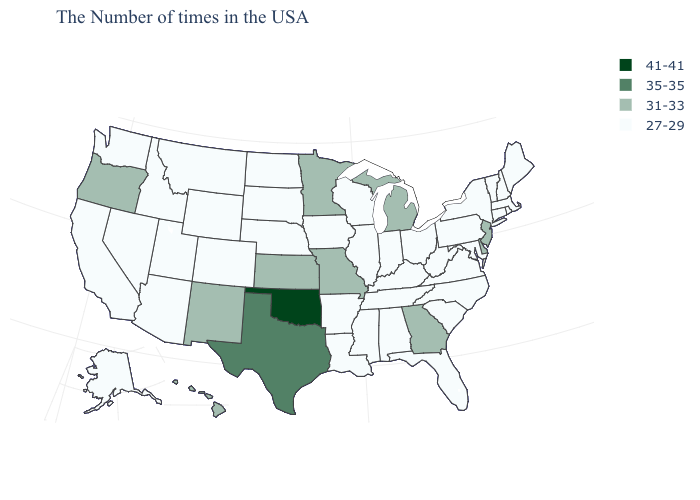What is the value of Maine?
Quick response, please. 27-29. Is the legend a continuous bar?
Give a very brief answer. No. Among the states that border Tennessee , does Mississippi have the lowest value?
Answer briefly. Yes. What is the highest value in states that border North Carolina?
Short answer required. 31-33. Among the states that border South Carolina , which have the highest value?
Answer briefly. Georgia. Which states have the lowest value in the USA?
Concise answer only. Maine, Massachusetts, Rhode Island, New Hampshire, Vermont, Connecticut, New York, Maryland, Pennsylvania, Virginia, North Carolina, South Carolina, West Virginia, Ohio, Florida, Kentucky, Indiana, Alabama, Tennessee, Wisconsin, Illinois, Mississippi, Louisiana, Arkansas, Iowa, Nebraska, South Dakota, North Dakota, Wyoming, Colorado, Utah, Montana, Arizona, Idaho, Nevada, California, Washington, Alaska. What is the highest value in the South ?
Keep it brief. 41-41. What is the value of California?
Quick response, please. 27-29. What is the highest value in states that border Wisconsin?
Keep it brief. 31-33. What is the value of Alabama?
Give a very brief answer. 27-29. Name the states that have a value in the range 31-33?
Be succinct. New Jersey, Delaware, Georgia, Michigan, Missouri, Minnesota, Kansas, New Mexico, Oregon, Hawaii. What is the value of Illinois?
Give a very brief answer. 27-29. Name the states that have a value in the range 31-33?
Keep it brief. New Jersey, Delaware, Georgia, Michigan, Missouri, Minnesota, Kansas, New Mexico, Oregon, Hawaii. How many symbols are there in the legend?
Be succinct. 4. 